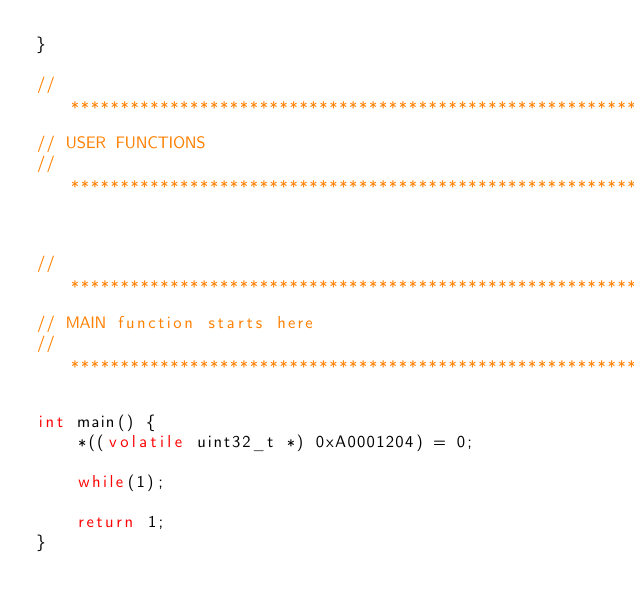<code> <loc_0><loc_0><loc_500><loc_500><_C_>}

//*******************************************************************
// USER FUNCTIONS
//*******************************************************************


//********************************************************************
// MAIN function starts here             
//********************************************************************

int main() {
    *((volatile uint32_t *) 0xA0001204) = 0;

    while(1);

    return 1;
}

</code> 